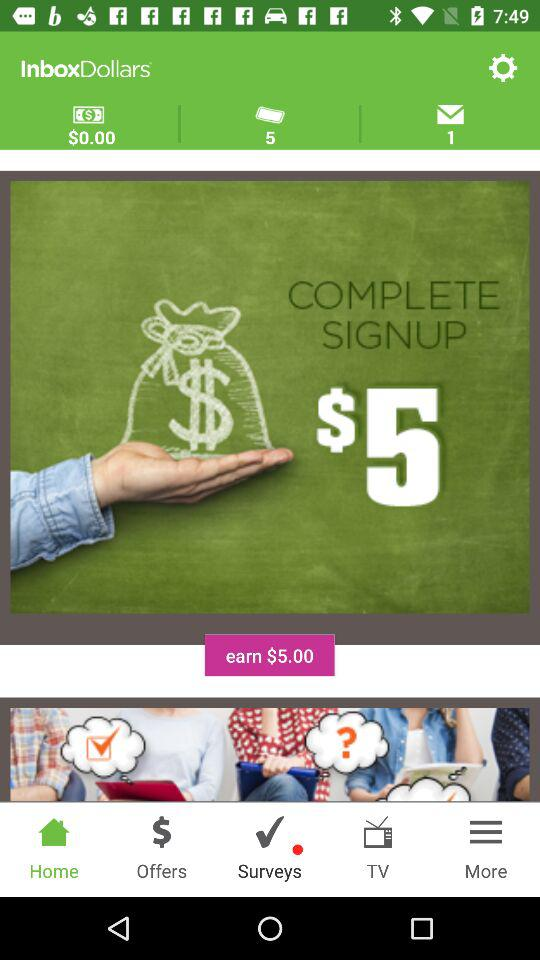How much can be earned after signing up? After signing up, $5 can be earned. 